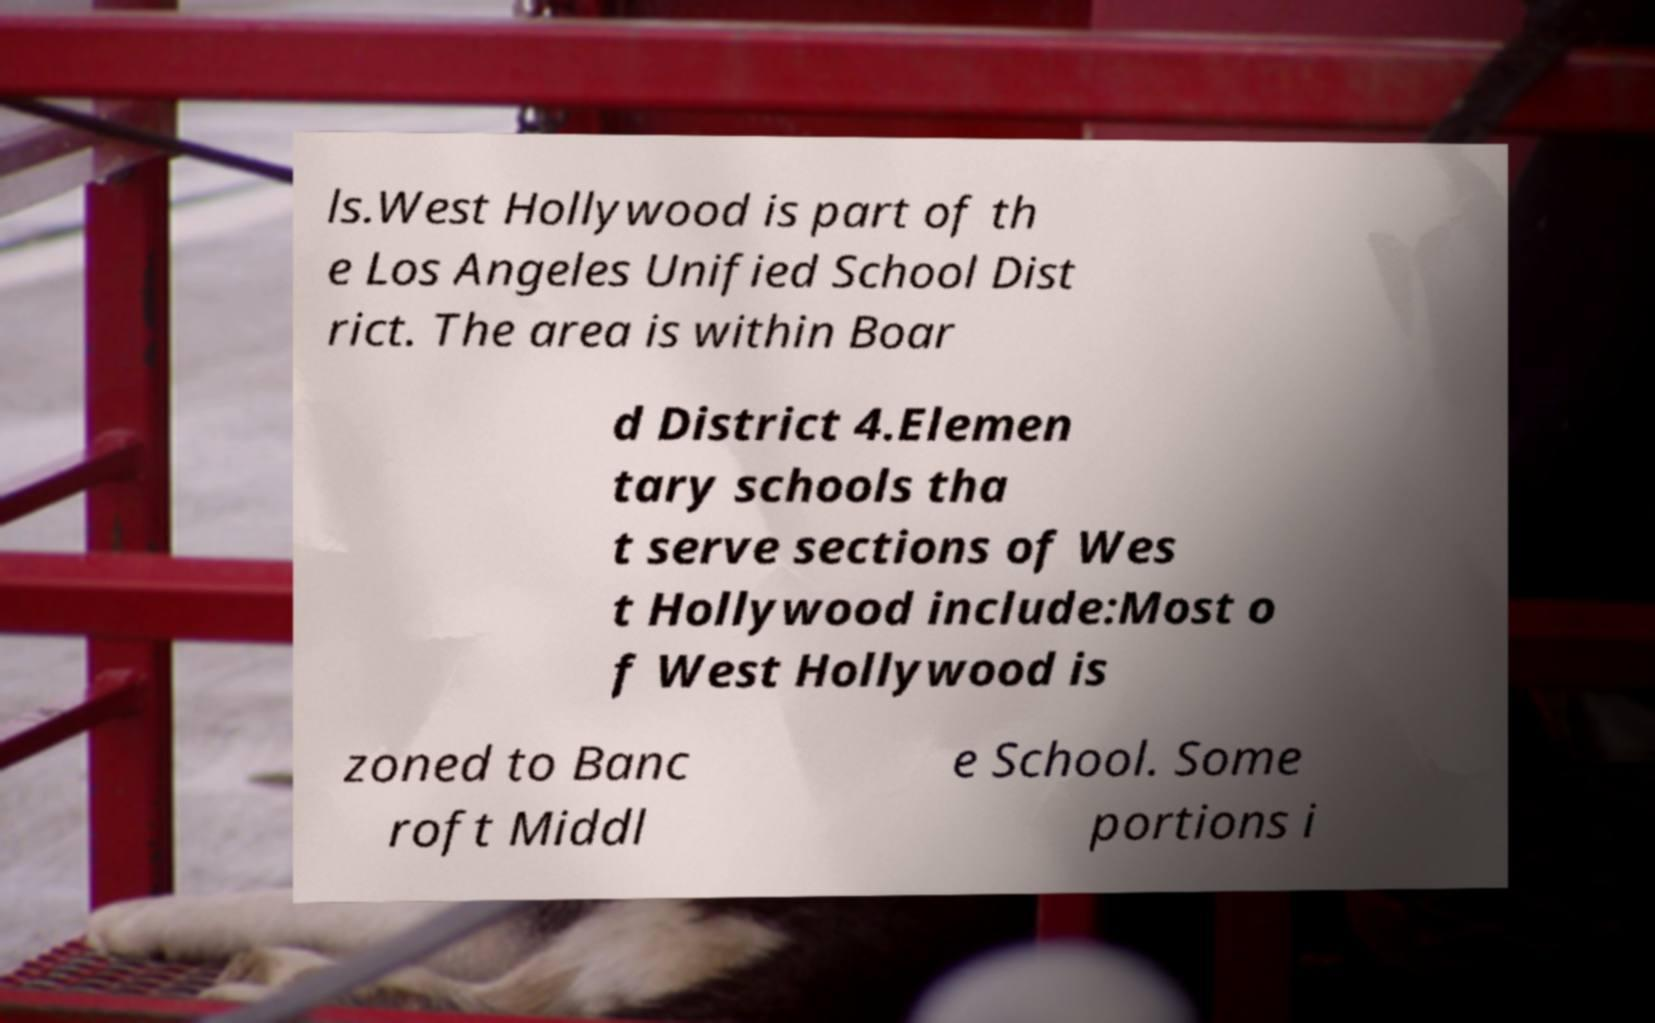Please identify and transcribe the text found in this image. ls.West Hollywood is part of th e Los Angeles Unified School Dist rict. The area is within Boar d District 4.Elemen tary schools tha t serve sections of Wes t Hollywood include:Most o f West Hollywood is zoned to Banc roft Middl e School. Some portions i 